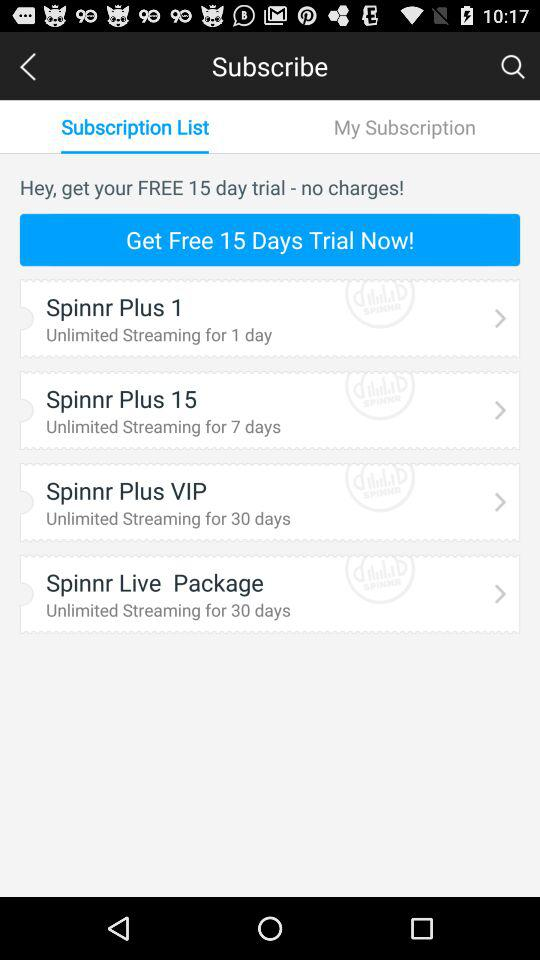How many trial days are there? There are 15 trial days. 